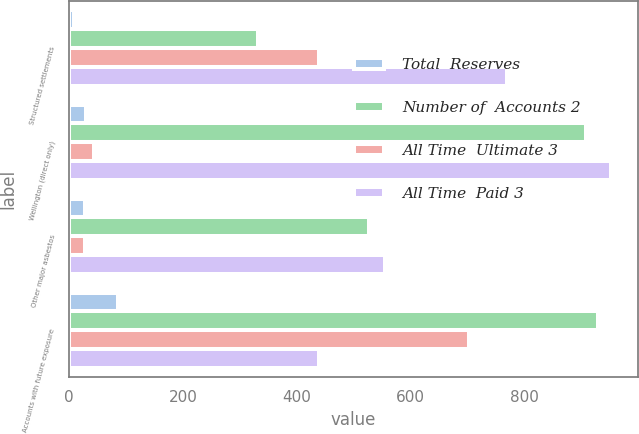Convert chart. <chart><loc_0><loc_0><loc_500><loc_500><stacked_bar_chart><ecel><fcel>Structured settlements<fcel>Wellington (direct only)<fcel>Other major asbestos<fcel>Accounts with future exposure<nl><fcel>Total  Reserves<fcel>8<fcel>29<fcel>28<fcel>85<nl><fcel>Number of  Accounts 2<fcel>331<fcel>908<fcel>527<fcel>929<nl><fcel>All Time  Ultimate 3<fcel>438<fcel>43<fcel>28<fcel>702<nl><fcel>All Time  Paid 3<fcel>769<fcel>951<fcel>555<fcel>438<nl></chart> 